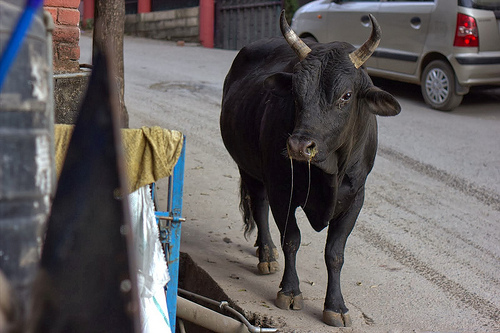<image>
Is there a cow on the car? No. The cow is not positioned on the car. They may be near each other, but the cow is not supported by or resting on top of the car. 